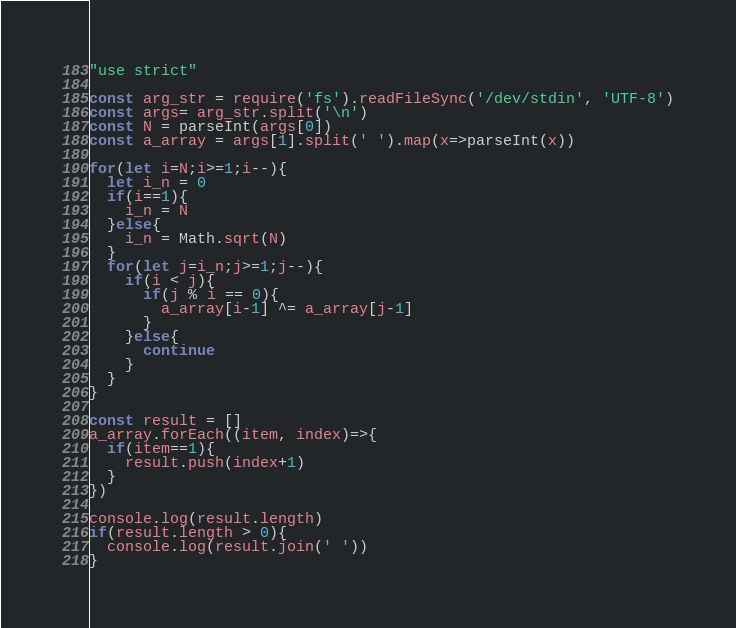Convert code to text. <code><loc_0><loc_0><loc_500><loc_500><_JavaScript_>"use strict"

const arg_str = require('fs').readFileSync('/dev/stdin', 'UTF-8')
const args= arg_str.split('\n')
const N = parseInt(args[0])
const a_array = args[1].split(' ').map(x=>parseInt(x))

for(let i=N;i>=1;i--){
  let i_n = 0
  if(i==1){
    i_n = N
  }else{
    i_n = Math.sqrt(N)
  }
  for(let j=i_n;j>=1;j--){
    if(i < j){
      if(j % i == 0){
        a_array[i-1] ^= a_array[j-1]
      }
    }else{
      continue
    }
  }
}

const result = []
a_array.forEach((item, index)=>{
  if(item==1){
    result.push(index+1)
  }
})

console.log(result.length)
if(result.length > 0){
  console.log(result.join(' '))
}
</code> 